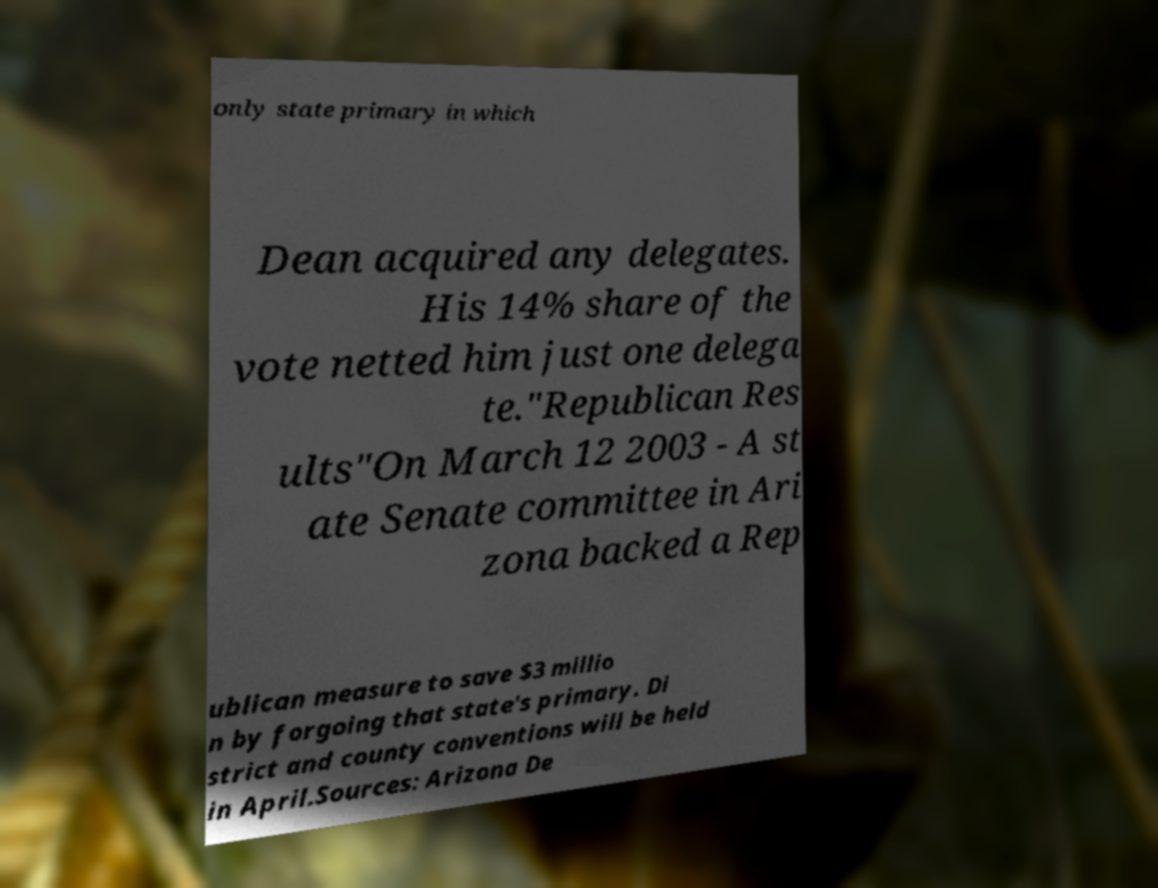Please read and relay the text visible in this image. What does it say? only state primary in which Dean acquired any delegates. His 14% share of the vote netted him just one delega te."Republican Res ults"On March 12 2003 - A st ate Senate committee in Ari zona backed a Rep ublican measure to save $3 millio n by forgoing that state's primary. Di strict and county conventions will be held in April.Sources: Arizona De 